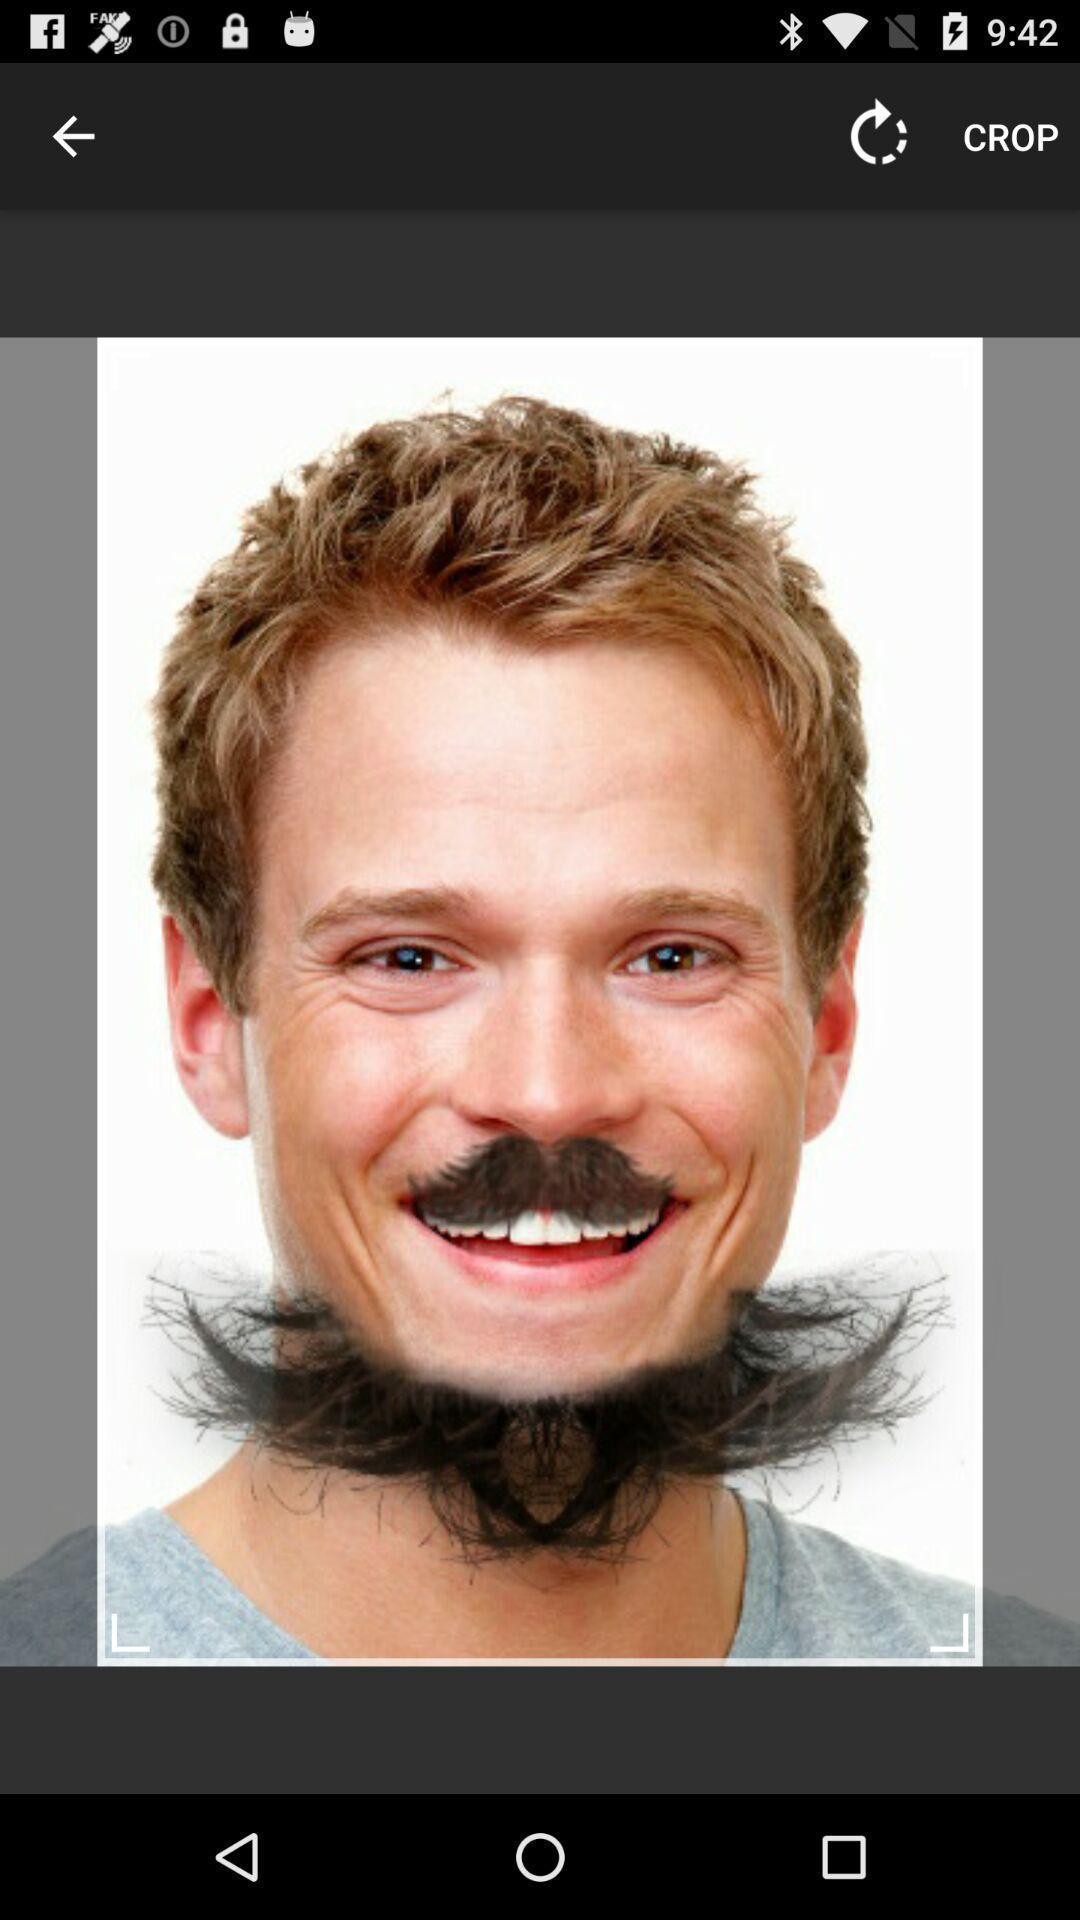What is the overall content of this screenshot? Screen showing an image with crop option. 